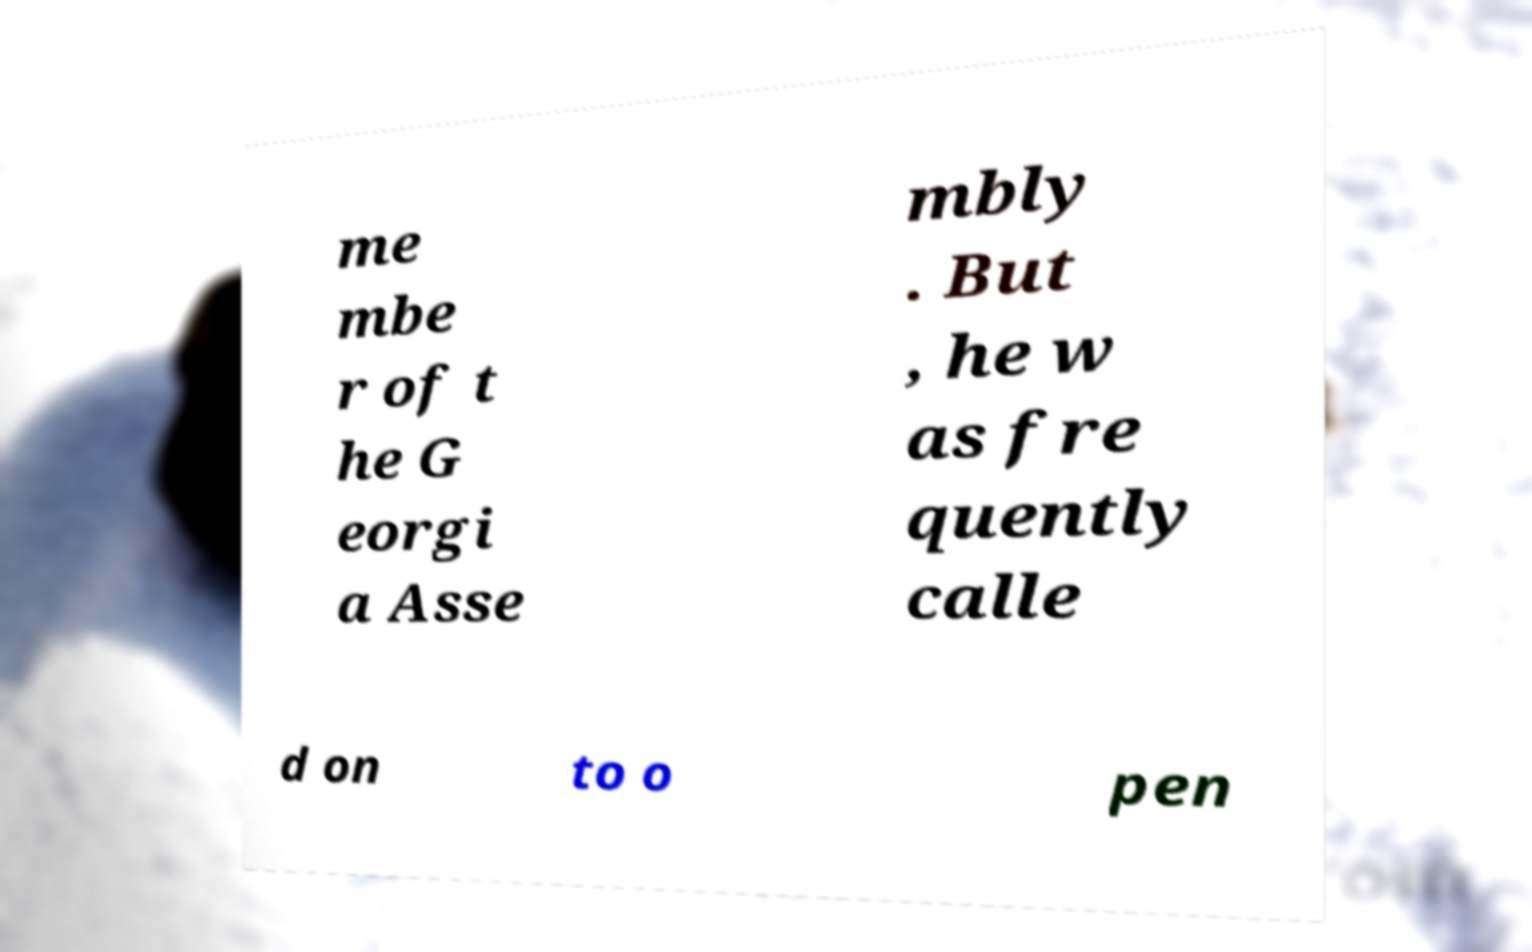Please read and relay the text visible in this image. What does it say? me mbe r of t he G eorgi a Asse mbly . But , he w as fre quently calle d on to o pen 